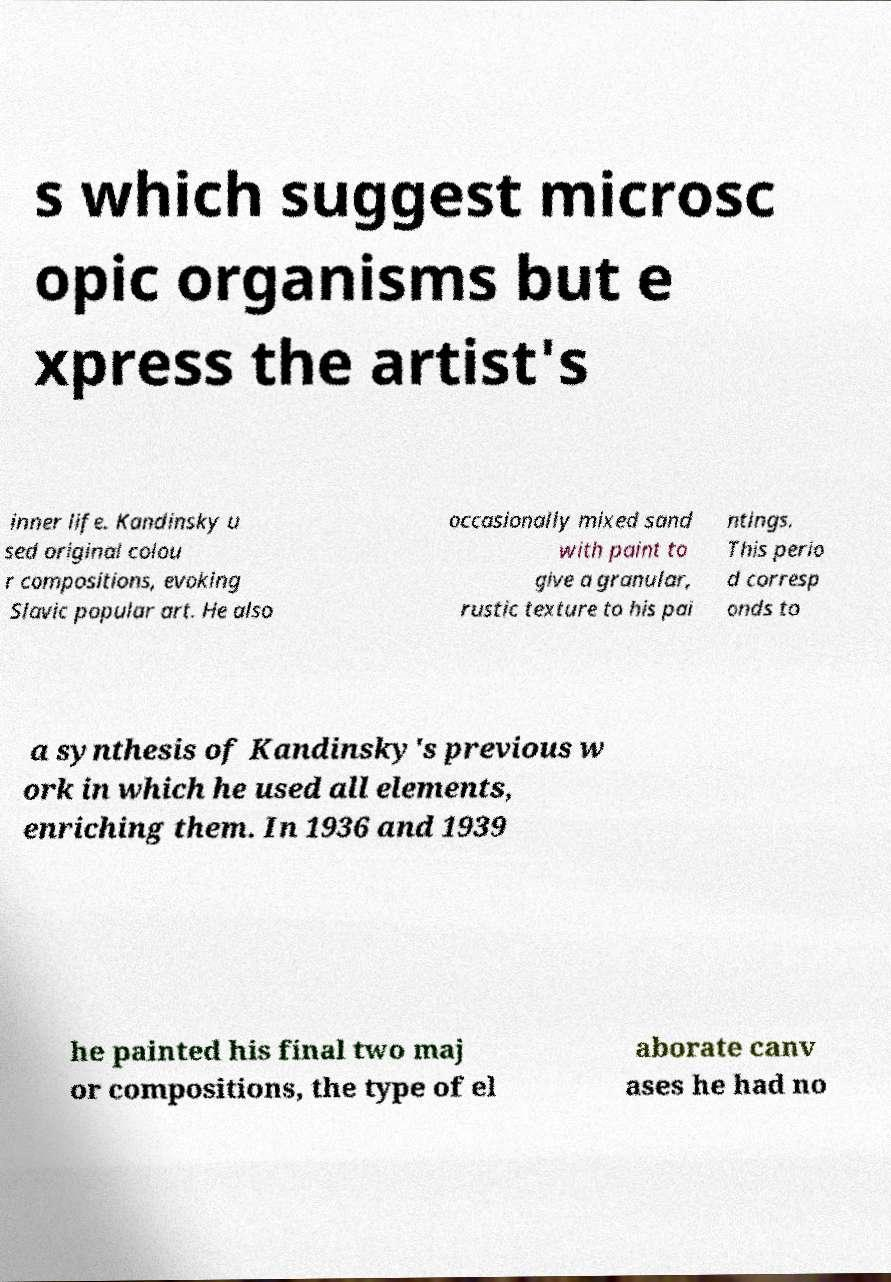Please read and relay the text visible in this image. What does it say? s which suggest microsc opic organisms but e xpress the artist's inner life. Kandinsky u sed original colou r compositions, evoking Slavic popular art. He also occasionally mixed sand with paint to give a granular, rustic texture to his pai ntings. This perio d corresp onds to a synthesis of Kandinsky's previous w ork in which he used all elements, enriching them. In 1936 and 1939 he painted his final two maj or compositions, the type of el aborate canv ases he had no 